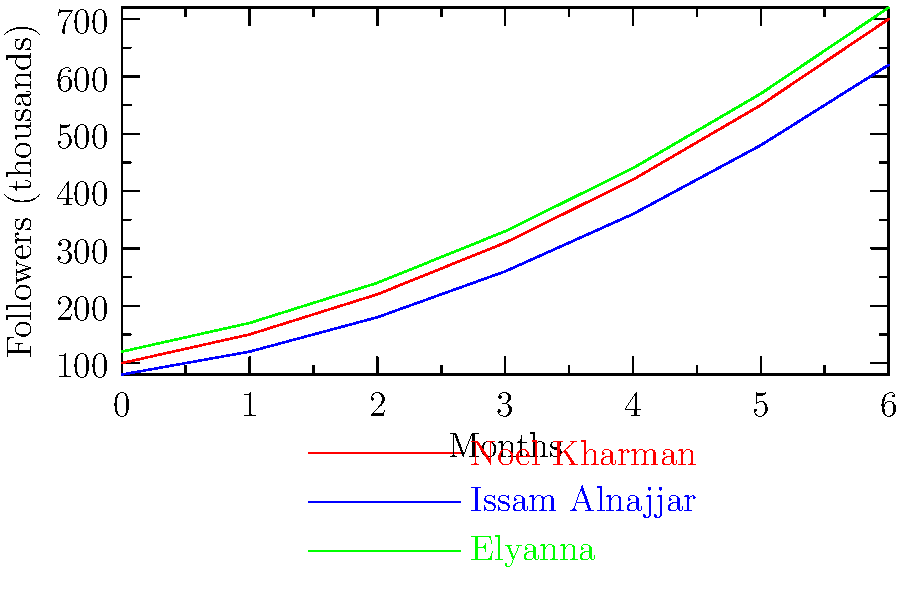Based on the graph showing the social media follower growth of emerging Arab artists over 6 months, which artist consistently maintained the highest number of followers throughout the entire period? To determine which artist consistently maintained the highest number of followers, we need to compare the three artists' follower counts at each data point:

1. Starting point (Month 0):
   Noel Kharman: 100,000
   Issam Alnajjar: 80,000
   Elyanna: 120,000

2. Month 1:
   Noel Kharman: 150,000
   Issam Alnajjar: 120,000
   Elyanna: 170,000

3. Month 2:
   Noel Kharman: 220,000
   Issam Alnajjar: 180,000
   Elyanna: 240,000

4. Month 3:
   Noel Kharman: 310,000
   Issam Alnajjar: 260,000
   Elyanna: 330,000

5. Month 4:
   Noel Kharman: 420,000
   Issam Alnajjar: 360,000
   Elyanna: 440,000

6. Month 5:
   Noel Kharman: 550,000
   Issam Alnajjar: 480,000
   Elyanna: 570,000

7. Month 6:
   Noel Kharman: 700,000
   Issam Alnajjar: 620,000
   Elyanna: 720,000

We can see that Elyanna (represented by the green line) consistently has the highest number of followers at each data point throughout the entire 6-month period.
Answer: Elyanna 